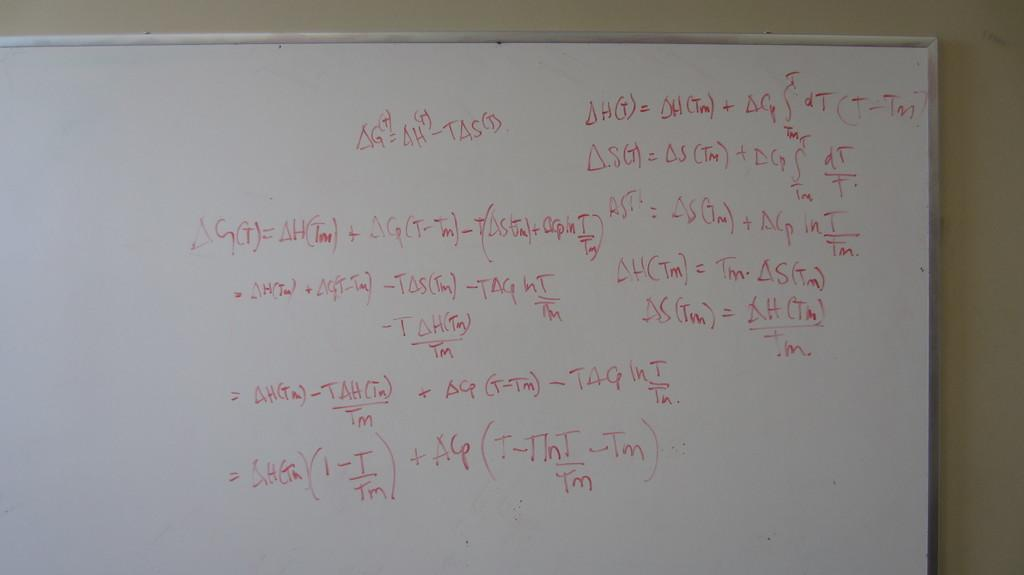<image>
Relay a brief, clear account of the picture shown. A white board is showing how to solve an equation G=H-TAS. 